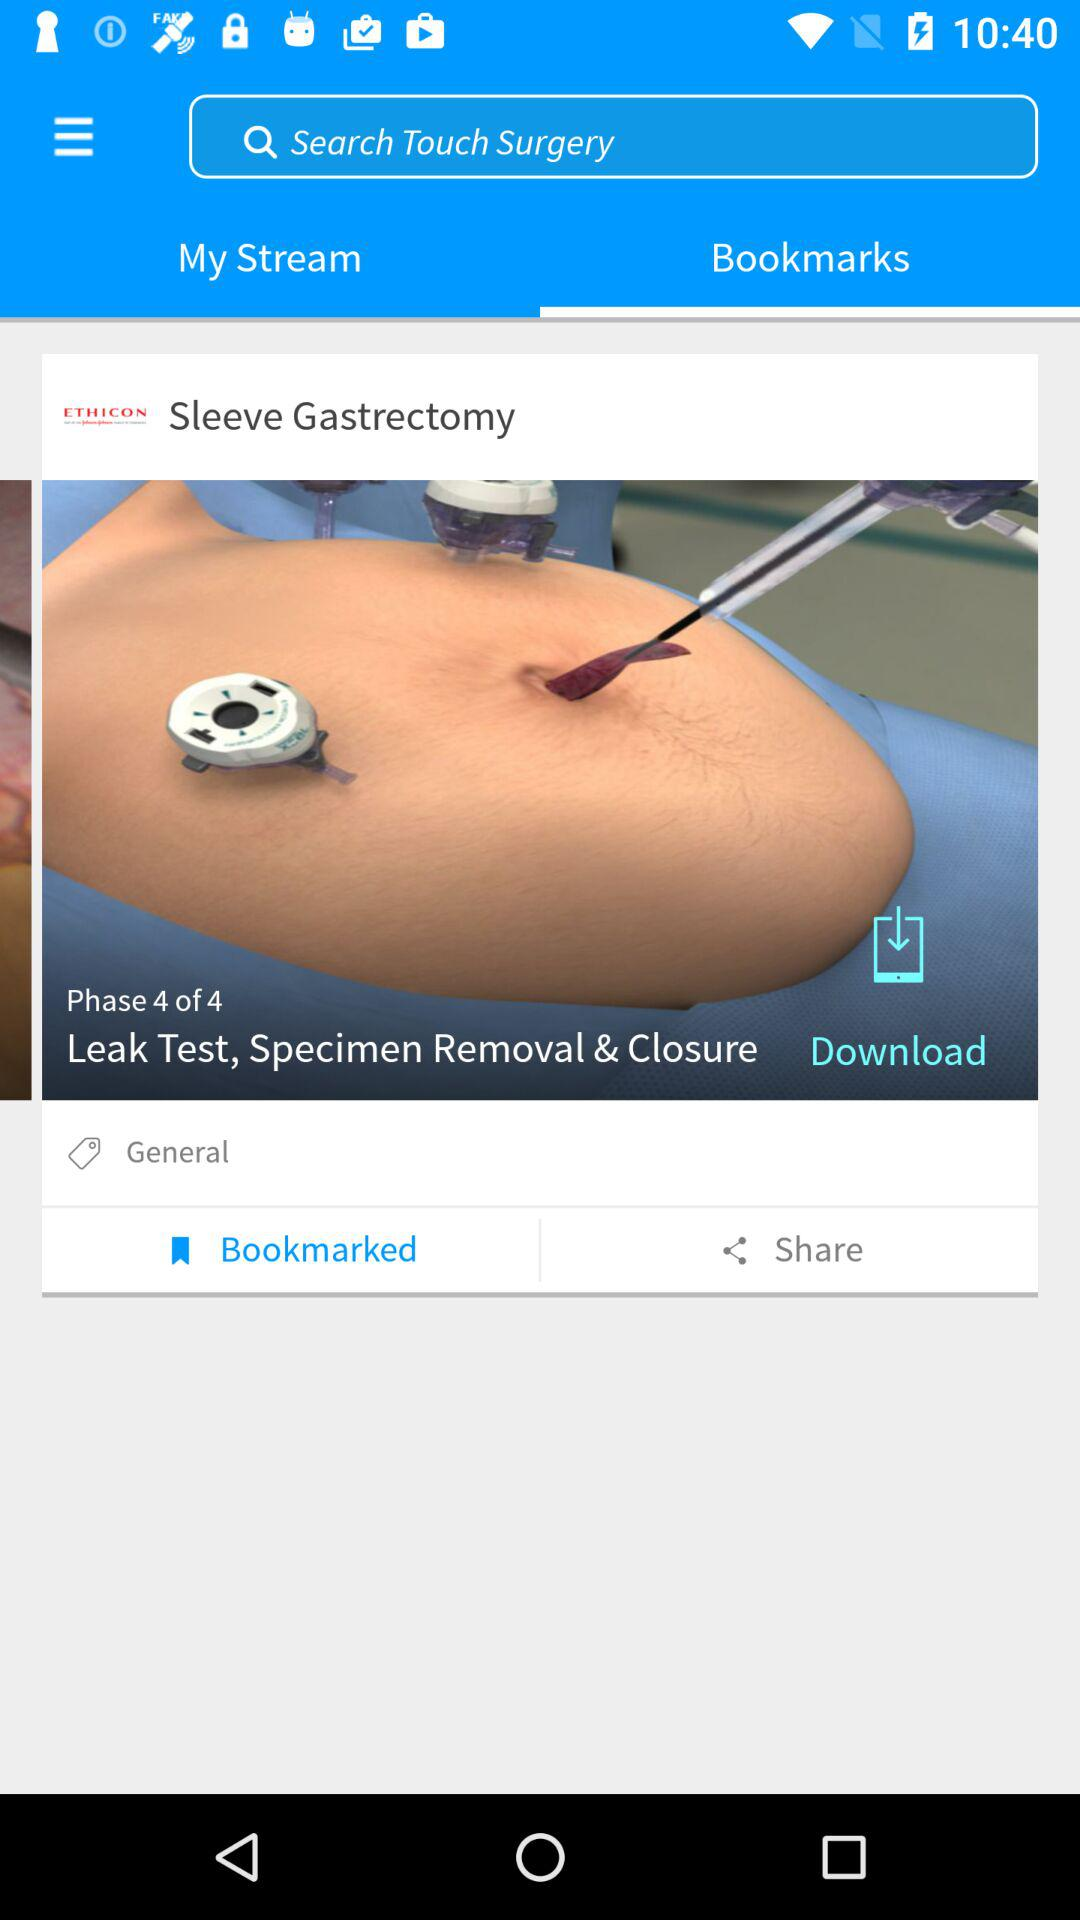What is the name of the surgery? The name of the surgery is "Sleeve Gastrectomy". 